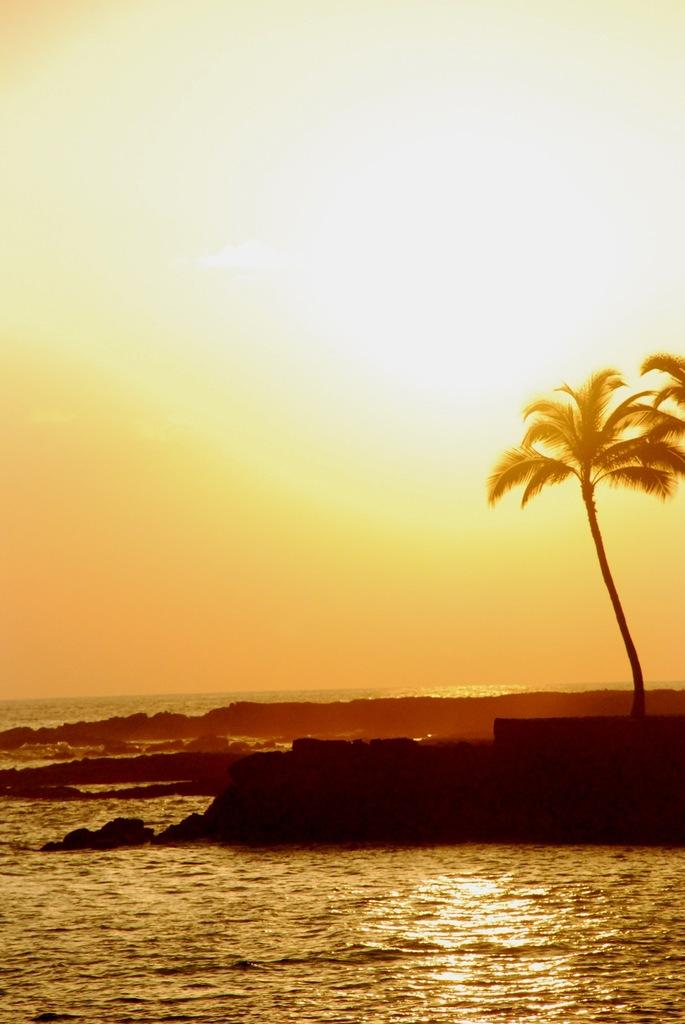What type of location is shown in the image? The image depicts a beach. What natural element can be seen on the right side of the image? There is a tree on the right side of the image. What is visible in the background of the image? The sky is visible in the background of the image. How many sponges are being used by the men in the image? There are no men or sponges present in the image. 